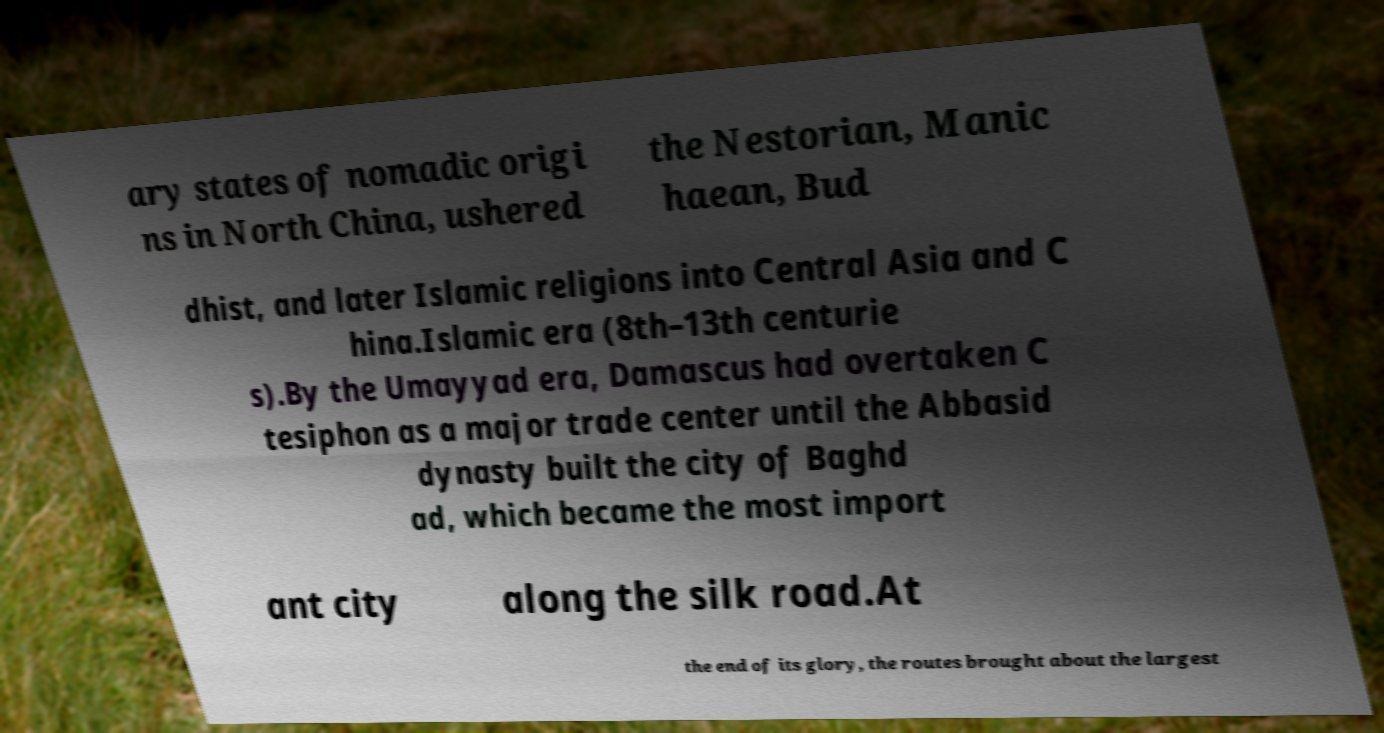What messages or text are displayed in this image? I need them in a readable, typed format. ary states of nomadic origi ns in North China, ushered the Nestorian, Manic haean, Bud dhist, and later Islamic religions into Central Asia and C hina.Islamic era (8th–13th centurie s).By the Umayyad era, Damascus had overtaken C tesiphon as a major trade center until the Abbasid dynasty built the city of Baghd ad, which became the most import ant city along the silk road.At the end of its glory, the routes brought about the largest 